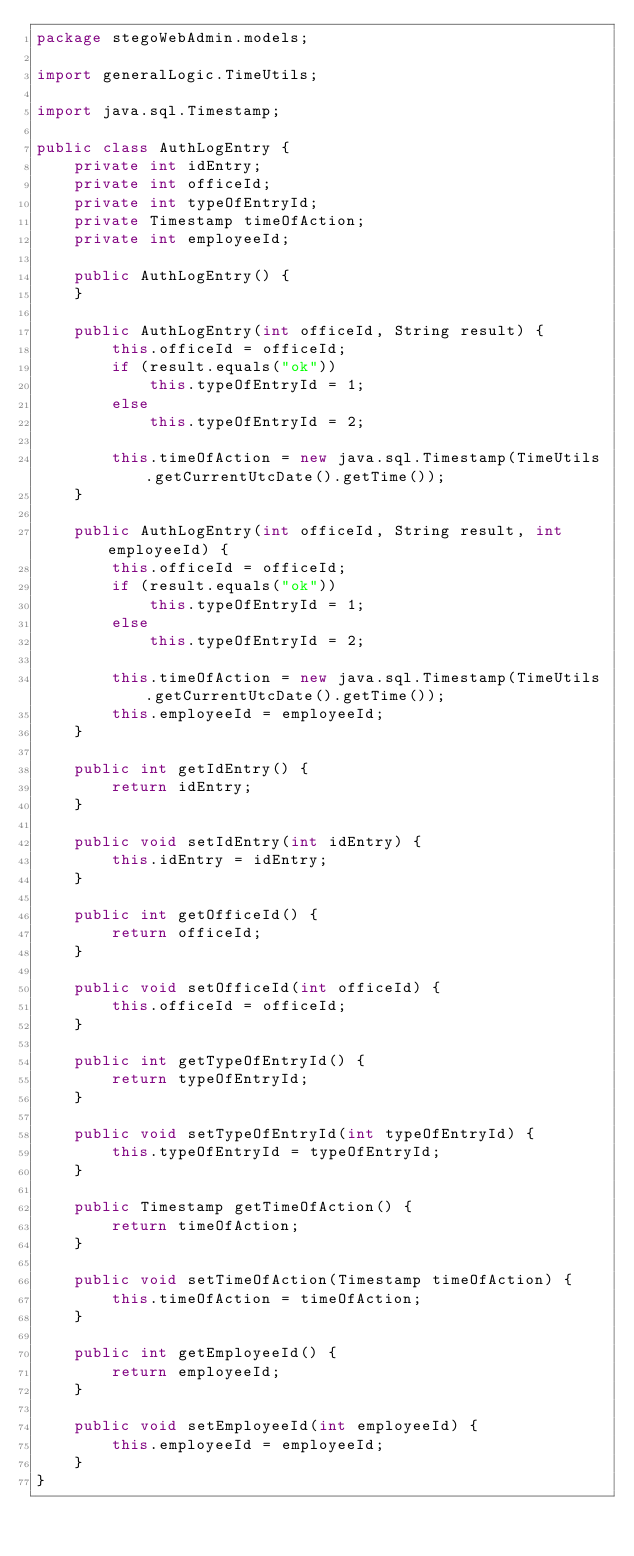<code> <loc_0><loc_0><loc_500><loc_500><_Java_>package stegoWebAdmin.models;

import generalLogic.TimeUtils;

import java.sql.Timestamp;

public class AuthLogEntry {
    private int idEntry;
    private int officeId;
    private int typeOfEntryId;
    private Timestamp timeOfAction;
    private int employeeId;

    public AuthLogEntry() {
    }

    public AuthLogEntry(int officeId, String result) {
        this.officeId = officeId;
        if (result.equals("ok"))
            this.typeOfEntryId = 1;
        else
            this.typeOfEntryId = 2;

        this.timeOfAction = new java.sql.Timestamp(TimeUtils.getCurrentUtcDate().getTime());
    }

    public AuthLogEntry(int officeId, String result, int employeeId) {
        this.officeId = officeId;
        if (result.equals("ok"))
            this.typeOfEntryId = 1;
        else
            this.typeOfEntryId = 2;

        this.timeOfAction = new java.sql.Timestamp(TimeUtils.getCurrentUtcDate().getTime());
        this.employeeId = employeeId;
    }

    public int getIdEntry() {
        return idEntry;
    }

    public void setIdEntry(int idEntry) {
        this.idEntry = idEntry;
    }

    public int getOfficeId() {
        return officeId;
    }

    public void setOfficeId(int officeId) {
        this.officeId = officeId;
    }

    public int getTypeOfEntryId() {
        return typeOfEntryId;
    }

    public void setTypeOfEntryId(int typeOfEntryId) {
        this.typeOfEntryId = typeOfEntryId;
    }

    public Timestamp getTimeOfAction() {
        return timeOfAction;
    }

    public void setTimeOfAction(Timestamp timeOfAction) {
        this.timeOfAction = timeOfAction;
    }

    public int getEmployeeId() {
        return employeeId;
    }

    public void setEmployeeId(int employeeId) {
        this.employeeId = employeeId;
    }
}
</code> 